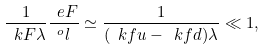Convert formula to latex. <formula><loc_0><loc_0><loc_500><loc_500>\frac { 1 } { \ k F \lambda } \frac { \ e F } { ^ { o } l } \simeq \frac { 1 } { ( \ k f u - \ k f d ) \lambda } \ll 1 ,</formula> 